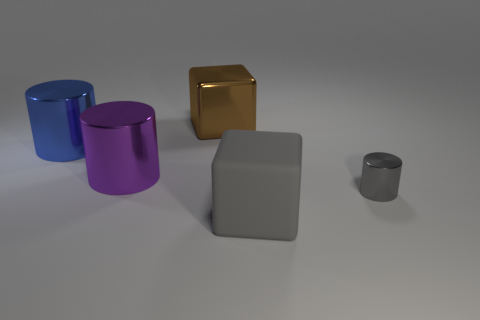What number of cylinders have the same size as the brown shiny cube?
Offer a very short reply. 2. Does the big block that is behind the gray block have the same material as the big gray cube?
Your answer should be very brief. No. Are there fewer brown shiny things that are on the left side of the brown block than brown things?
Provide a succinct answer. Yes. What shape is the big shiny thing that is to the right of the purple metallic thing?
Provide a succinct answer. Cube. There is a blue metal object that is the same size as the purple metallic cylinder; what shape is it?
Give a very brief answer. Cylinder. Are there any gray rubber things that have the same shape as the big brown shiny object?
Provide a short and direct response. Yes. There is a large object that is in front of the tiny gray thing; does it have the same shape as the large purple metallic thing that is behind the large matte block?
Make the answer very short. No. There is a blue cylinder that is the same size as the matte cube; what is it made of?
Provide a short and direct response. Metal. What number of other things are the same material as the tiny thing?
Provide a succinct answer. 3. What shape is the metallic object that is to the right of the metallic thing behind the blue metallic cylinder?
Your response must be concise. Cylinder. 